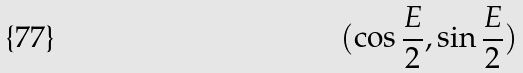<formula> <loc_0><loc_0><loc_500><loc_500>( \cos \frac { E } { 2 } , \sin \frac { E } { 2 } )</formula> 